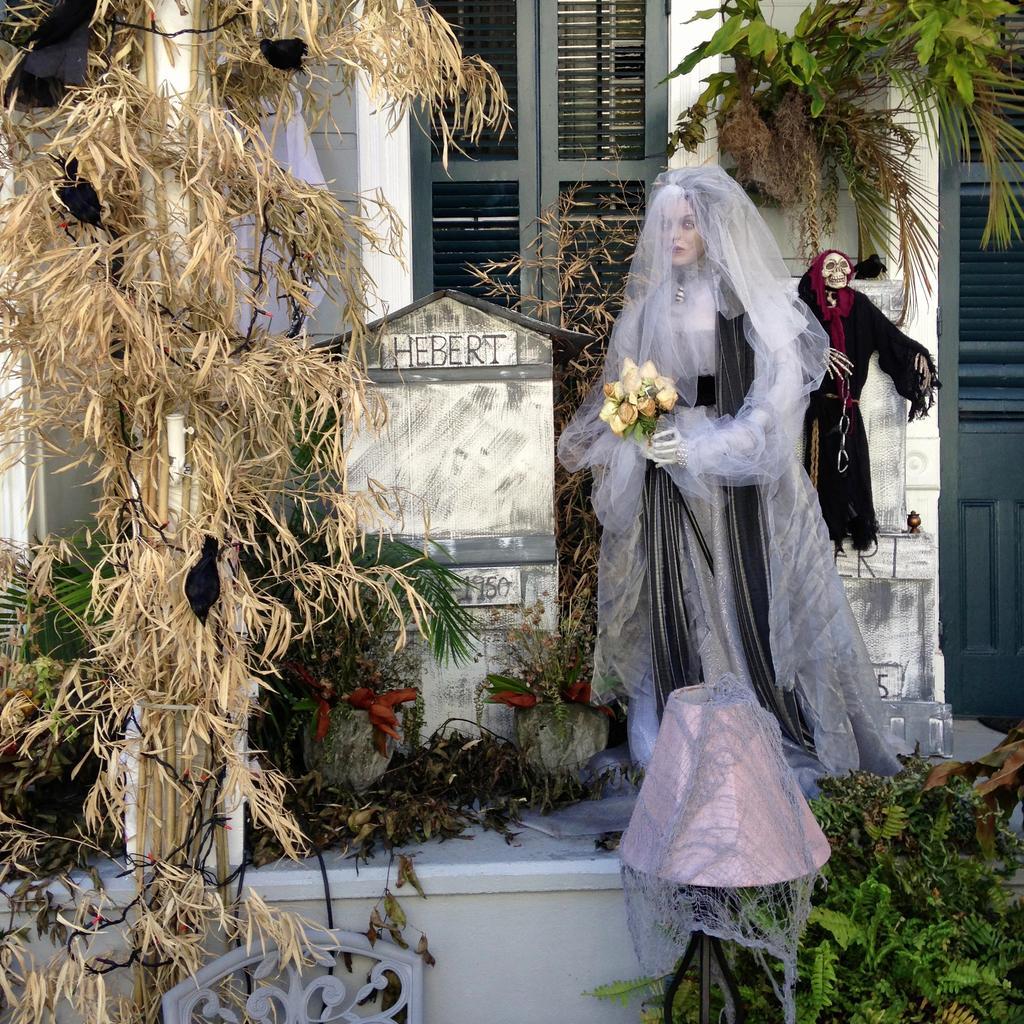In one or two sentences, can you explain what this image depicts? In this picture I can see there is a grave and there is a doll of woman standing on to right and there is a skeleton in the backdrop wearing a black dress and there are few plants and there is a window and a door. 